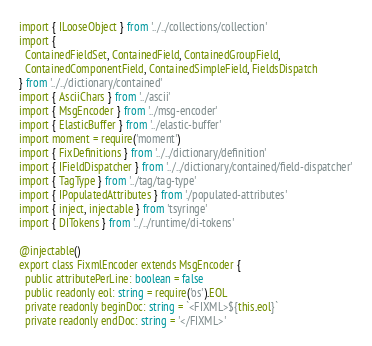<code> <loc_0><loc_0><loc_500><loc_500><_TypeScript_>import { ILooseObject } from '../../collections/collection'
import {
  ContainedFieldSet, ContainedField, ContainedGroupField,
  ContainedComponentField, ContainedSimpleField, FieldsDispatch
} from '../../dictionary/contained'
import { AsciiChars } from '../ascii'
import { MsgEncoder } from '../msg-encoder'
import { ElasticBuffer } from '../elastic-buffer'
import moment = require('moment')
import { FixDefinitions } from '../../dictionary/definition'
import { IFieldDispatcher } from '../../dictionary/contained/field-dispatcher'
import { TagType } from '../tag/tag-type'
import { IPopulatedAttributes } from './populated-attributes'
import { inject, injectable } from 'tsyringe'
import { DITokens } from '../../runtime/di-tokens'

@injectable()
export class FixmlEncoder extends MsgEncoder {
  public attributePerLine: boolean = false
  public readonly eol: string = require('os').EOL
  private readonly beginDoc: string = `<FIXML>${this.eol}`
  private readonly endDoc: string = '</FIXML>'</code> 